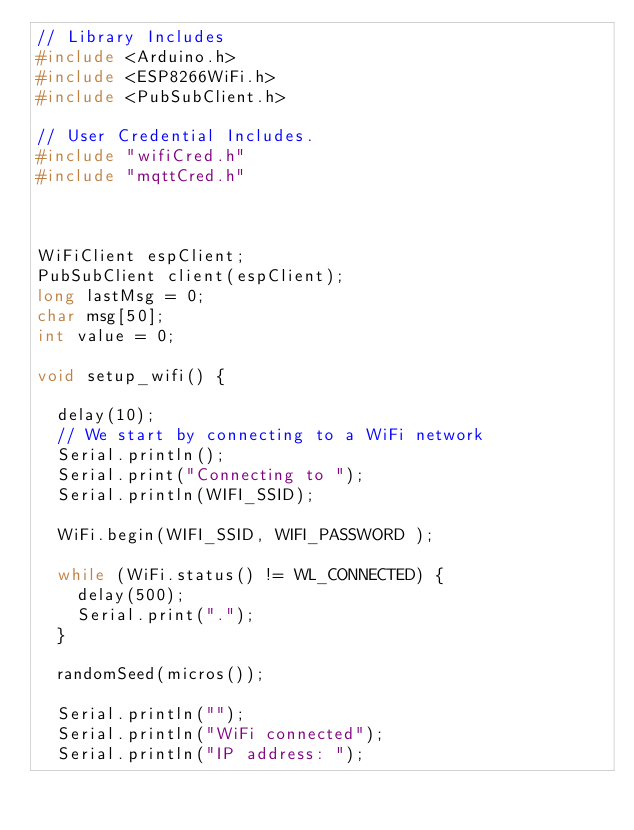Convert code to text. <code><loc_0><loc_0><loc_500><loc_500><_C++_>// Library Includes
#include <Arduino.h>
#include <ESP8266WiFi.h>
#include <PubSubClient.h>

// User Credential Includes.
#include "wifiCred.h"
#include "mqttCred.h"



WiFiClient espClient;
PubSubClient client(espClient);
long lastMsg = 0;
char msg[50];
int value = 0;

void setup_wifi() {

  delay(10);
  // We start by connecting to a WiFi network
  Serial.println();
  Serial.print("Connecting to ");
  Serial.println(WIFI_SSID);

  WiFi.begin(WIFI_SSID, WIFI_PASSWORD );

  while (WiFi.status() != WL_CONNECTED) {
    delay(500);
    Serial.print(".");
  }

  randomSeed(micros());

  Serial.println("");
  Serial.println("WiFi connected");
  Serial.println("IP address: ");</code> 